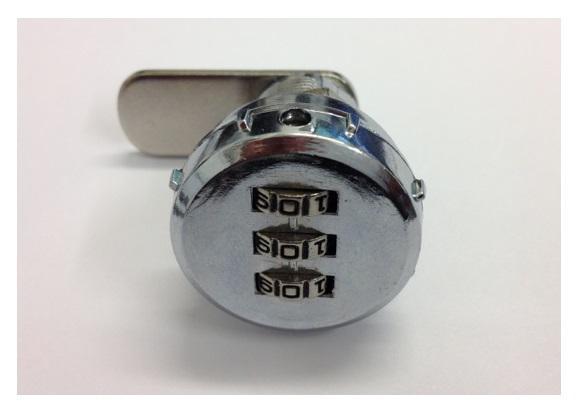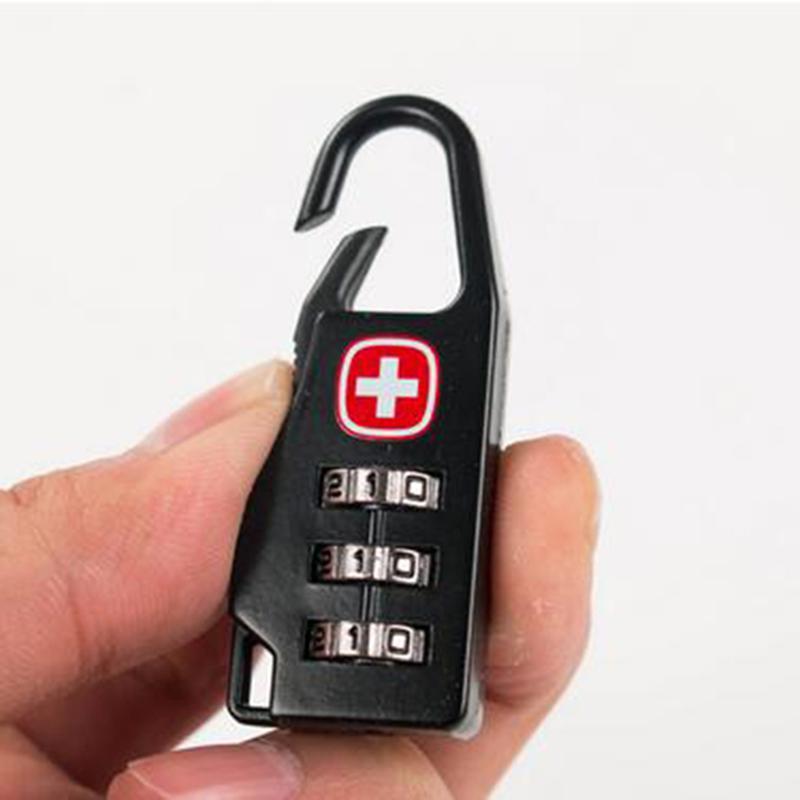The first image is the image on the left, the second image is the image on the right. Given the left and right images, does the statement "The lock in the image on the right is silver metal." hold true? Answer yes or no. No. The first image is the image on the left, the second image is the image on the right. For the images displayed, is the sentence "Of two locks, one is all metal with sliding number belts on the side, while the other has the number belts in a different position and a white cord lock loop." factually correct? Answer yes or no. No. 